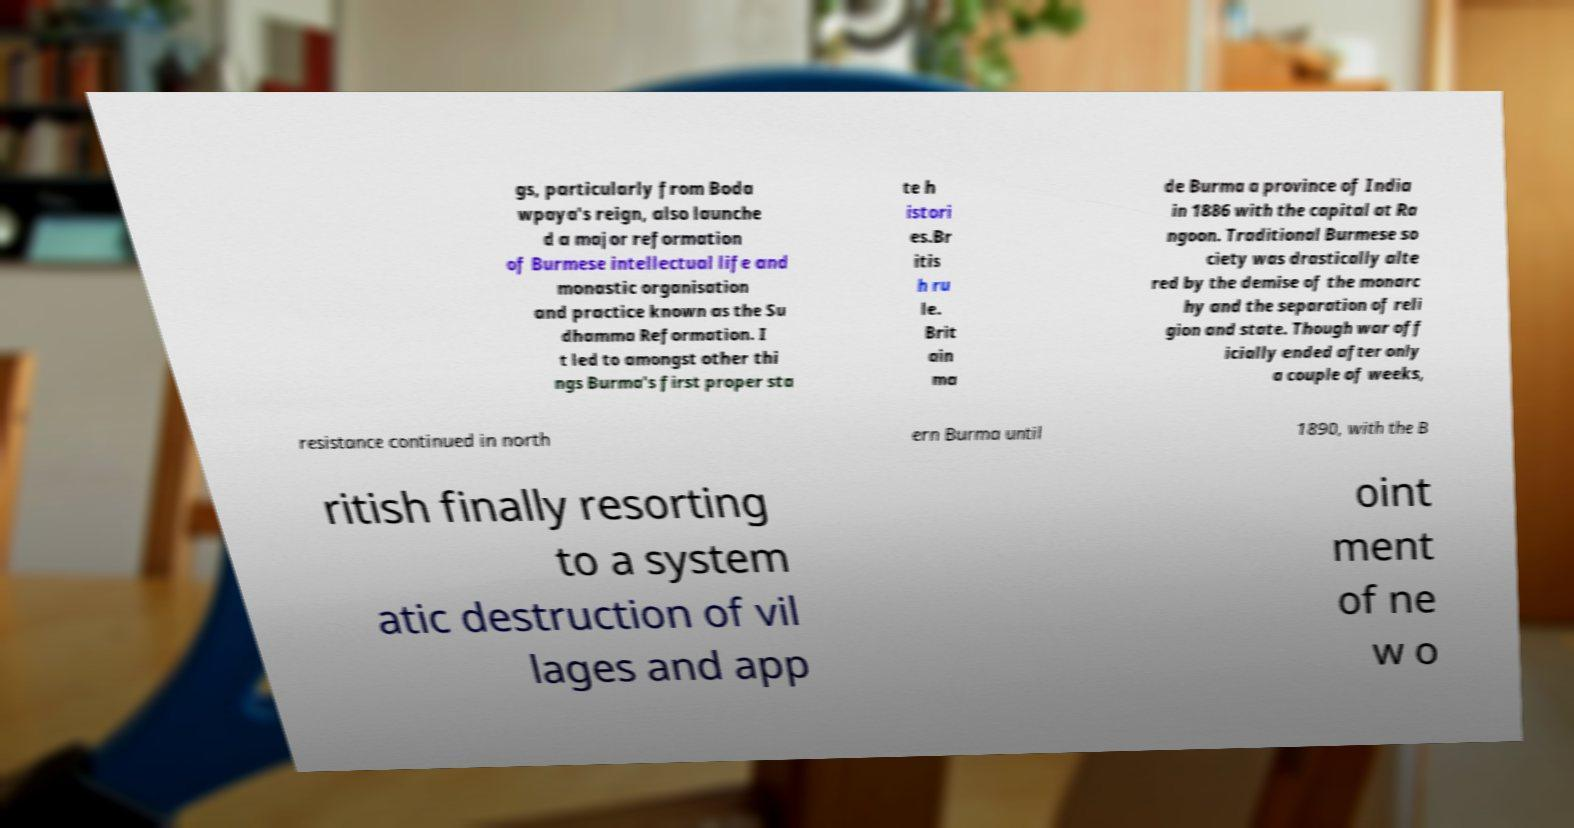Please identify and transcribe the text found in this image. gs, particularly from Boda wpaya's reign, also launche d a major reformation of Burmese intellectual life and monastic organisation and practice known as the Su dhamma Reformation. I t led to amongst other thi ngs Burma's first proper sta te h istori es.Br itis h ru le. Brit ain ma de Burma a province of India in 1886 with the capital at Ra ngoon. Traditional Burmese so ciety was drastically alte red by the demise of the monarc hy and the separation of reli gion and state. Though war off icially ended after only a couple of weeks, resistance continued in north ern Burma until 1890, with the B ritish finally resorting to a system atic destruction of vil lages and app oint ment of ne w o 